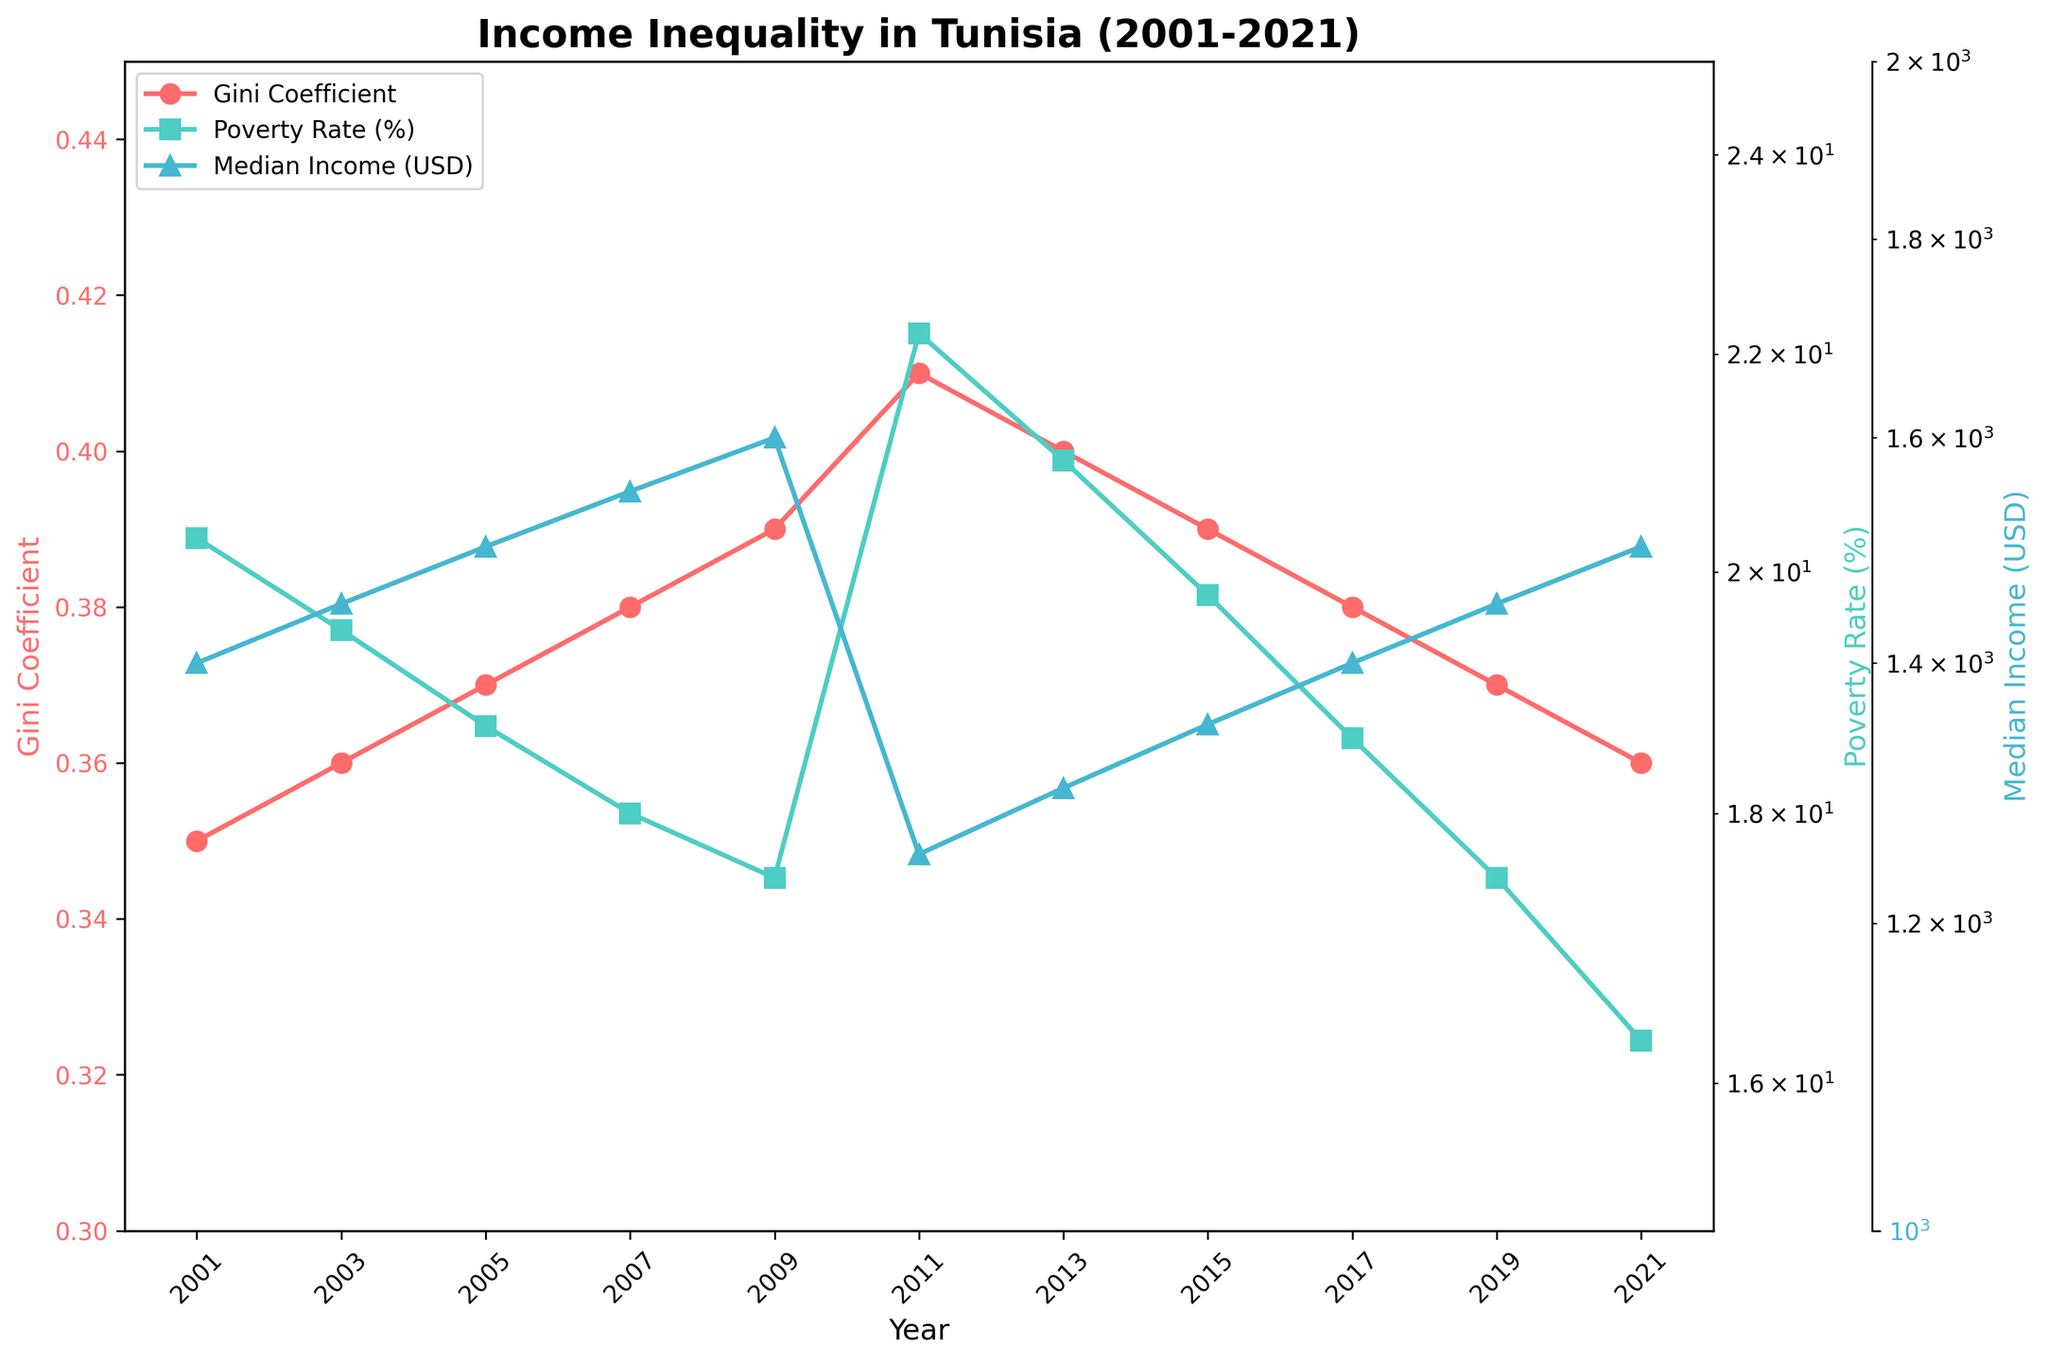What is the title of the figure? The title is usually placed at the top of the figure and describes the main subject being presented.
Answer: Income Inequality in Tunisia (2001-2021) How many years are covered in this figure? The x-axis of the plot lists the years from 2001 to 2021. Counting the intervals, there are 11 years included.
Answer: 11 What is the highest recorded Gini Coefficient in the figure? The Gini Coefficient values are plotted with markers. The highest value recorded on the y-axis for the Gini Coefficient is 0.41.
Answer: 0.41 In which year did the Poverty Rate peak, and what was the value? The Poverty Rate is indicated on the right y-axis. The peak value is observed in 2011, where the Poverty Rate is 22.2%.
Answer: 2011, 22.2% How did the Median Income change between 2011 and 2013? From the plot, the Median Income dropped from 1250 USD in 2011 to 1300 USD in 2013. The change is calculated as 1300 - 1250 = 50 USD.
Answer: It increased by 50 USD Compare the Gini Coefficient's trend from 2001 to 2011 versus from 2011 to 2021. The Gini Coefficient increased from 0.35 in 2001 to 0.41 in 2011, showing a rising trend. From 2011 to 2021, it decreased to 0.36, indicating a declining trend.
Answer: Rising trend from 2001-2011, declining trend from 2011-2021 Which year had the lowest Median Income, and what was the value? Median Income data points can be identified by the markers. The lowest value is 1250 USD, which is seen in the year 2011.
Answer: 2011, 1250 USD By what percentage did the Poverty Rate change from 2003 to 2013? The Poverty Rate was 19.5% in 2003 and 21.0% in 2013. The percentage change is calculated as ((21.0 - 19.5) / 19.5) * 100 = 7.69%.
Answer: Approximately 7.69% Identify the colors used for each variable in the plot and the corresponding y-axis they represent. The Gini Coefficient is represented in red and corresponds to the left y-axis. The Poverty Rate is shown in green and aligns with the right y-axis. The Median Income, shown in blue, corresponds to an additional right y-axis.
Answer: Gini Coefficient (red, left y-axis), Poverty Rate (green, right y-axis), Median Income (blue, additional right y-axis) Is there any year where Median Income, Gini Coefficient, and Poverty Rate all decreased simultaneously? By examining the plotted data points, it is evident that none of the years show a simultaneous decrease in all three values.
Answer: No 